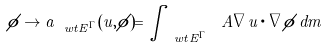Convert formula to latex. <formula><loc_0><loc_0><loc_500><loc_500>\phi \to a _ { \ w t { E ^ { \Gamma } } } ( u , \phi ) = \int _ { \ w t { E ^ { \Gamma } } } \ A \nabla u \cdot \nabla \phi \, d m</formula> 